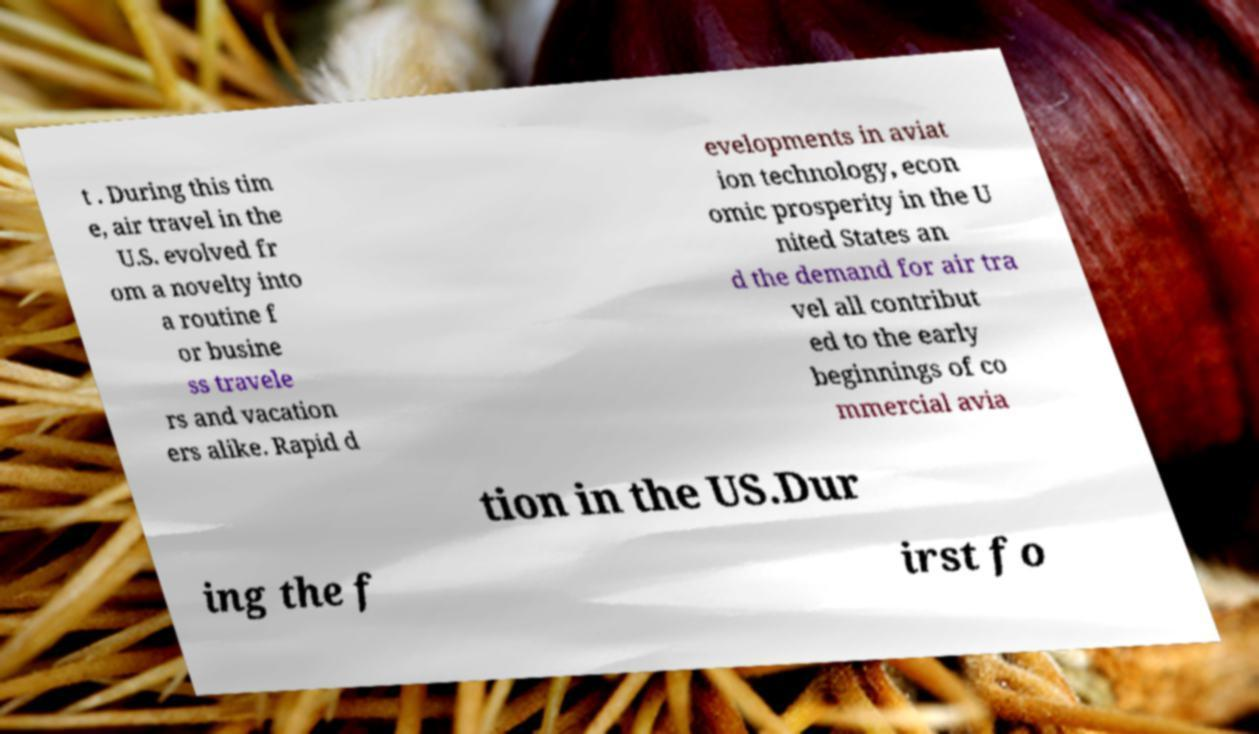For documentation purposes, I need the text within this image transcribed. Could you provide that? t . During this tim e, air travel in the U.S. evolved fr om a novelty into a routine f or busine ss travele rs and vacation ers alike. Rapid d evelopments in aviat ion technology, econ omic prosperity in the U nited States an d the demand for air tra vel all contribut ed to the early beginnings of co mmercial avia tion in the US.Dur ing the f irst fo 